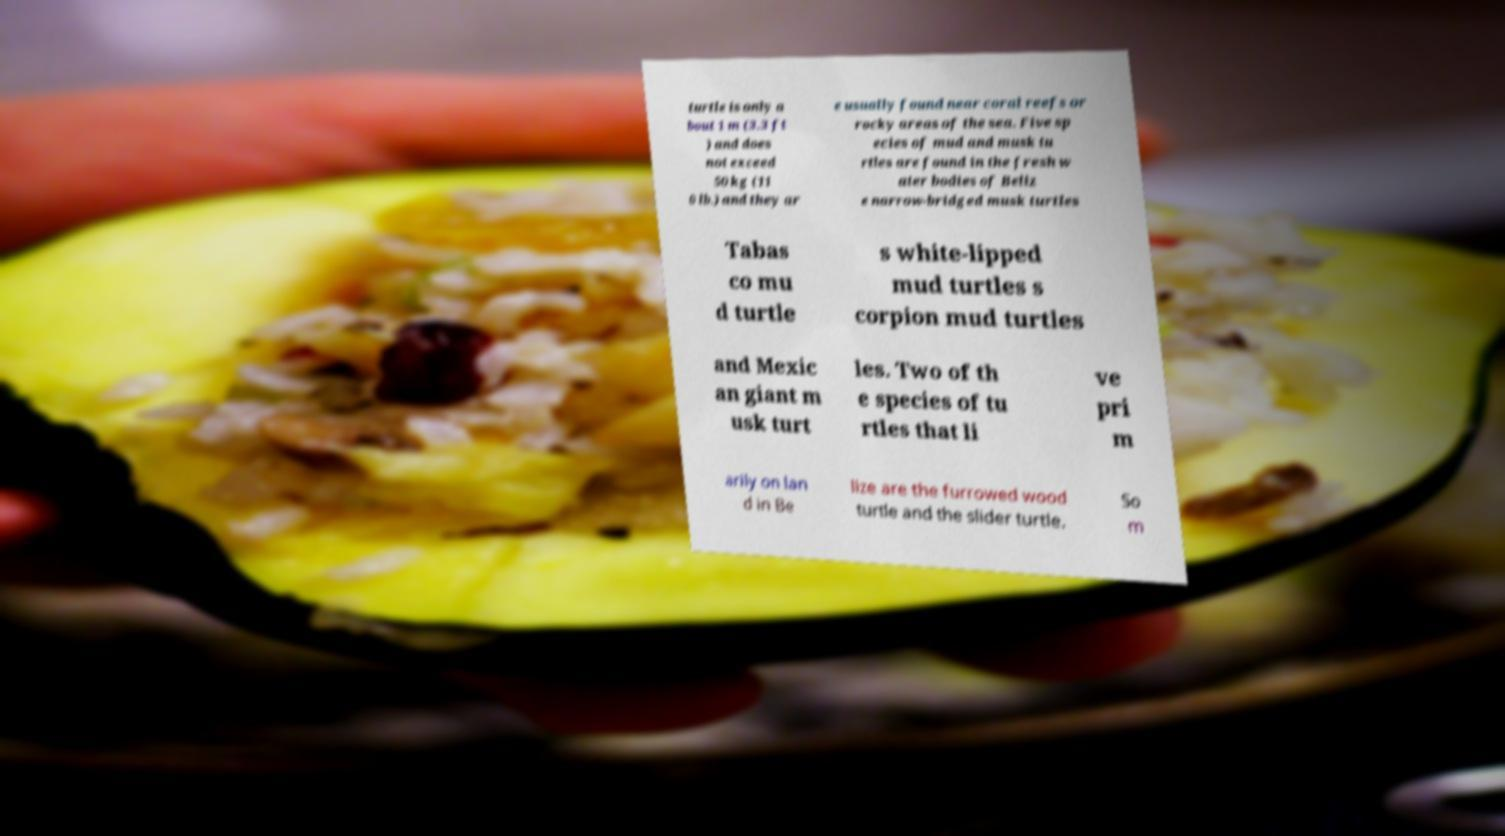I need the written content from this picture converted into text. Can you do that? turtle is only a bout 1 m (3.3 ft ) and does not exceed 50 kg (11 0 lb.) and they ar e usually found near coral reefs or rocky areas of the sea. Five sp ecies of mud and musk tu rtles are found in the fresh w ater bodies of Beliz e narrow-bridged musk turtles Tabas co mu d turtle s white-lipped mud turtles s corpion mud turtles and Mexic an giant m usk turt les. Two of th e species of tu rtles that li ve pri m arily on lan d in Be lize are the furrowed wood turtle and the slider turtle. So m 